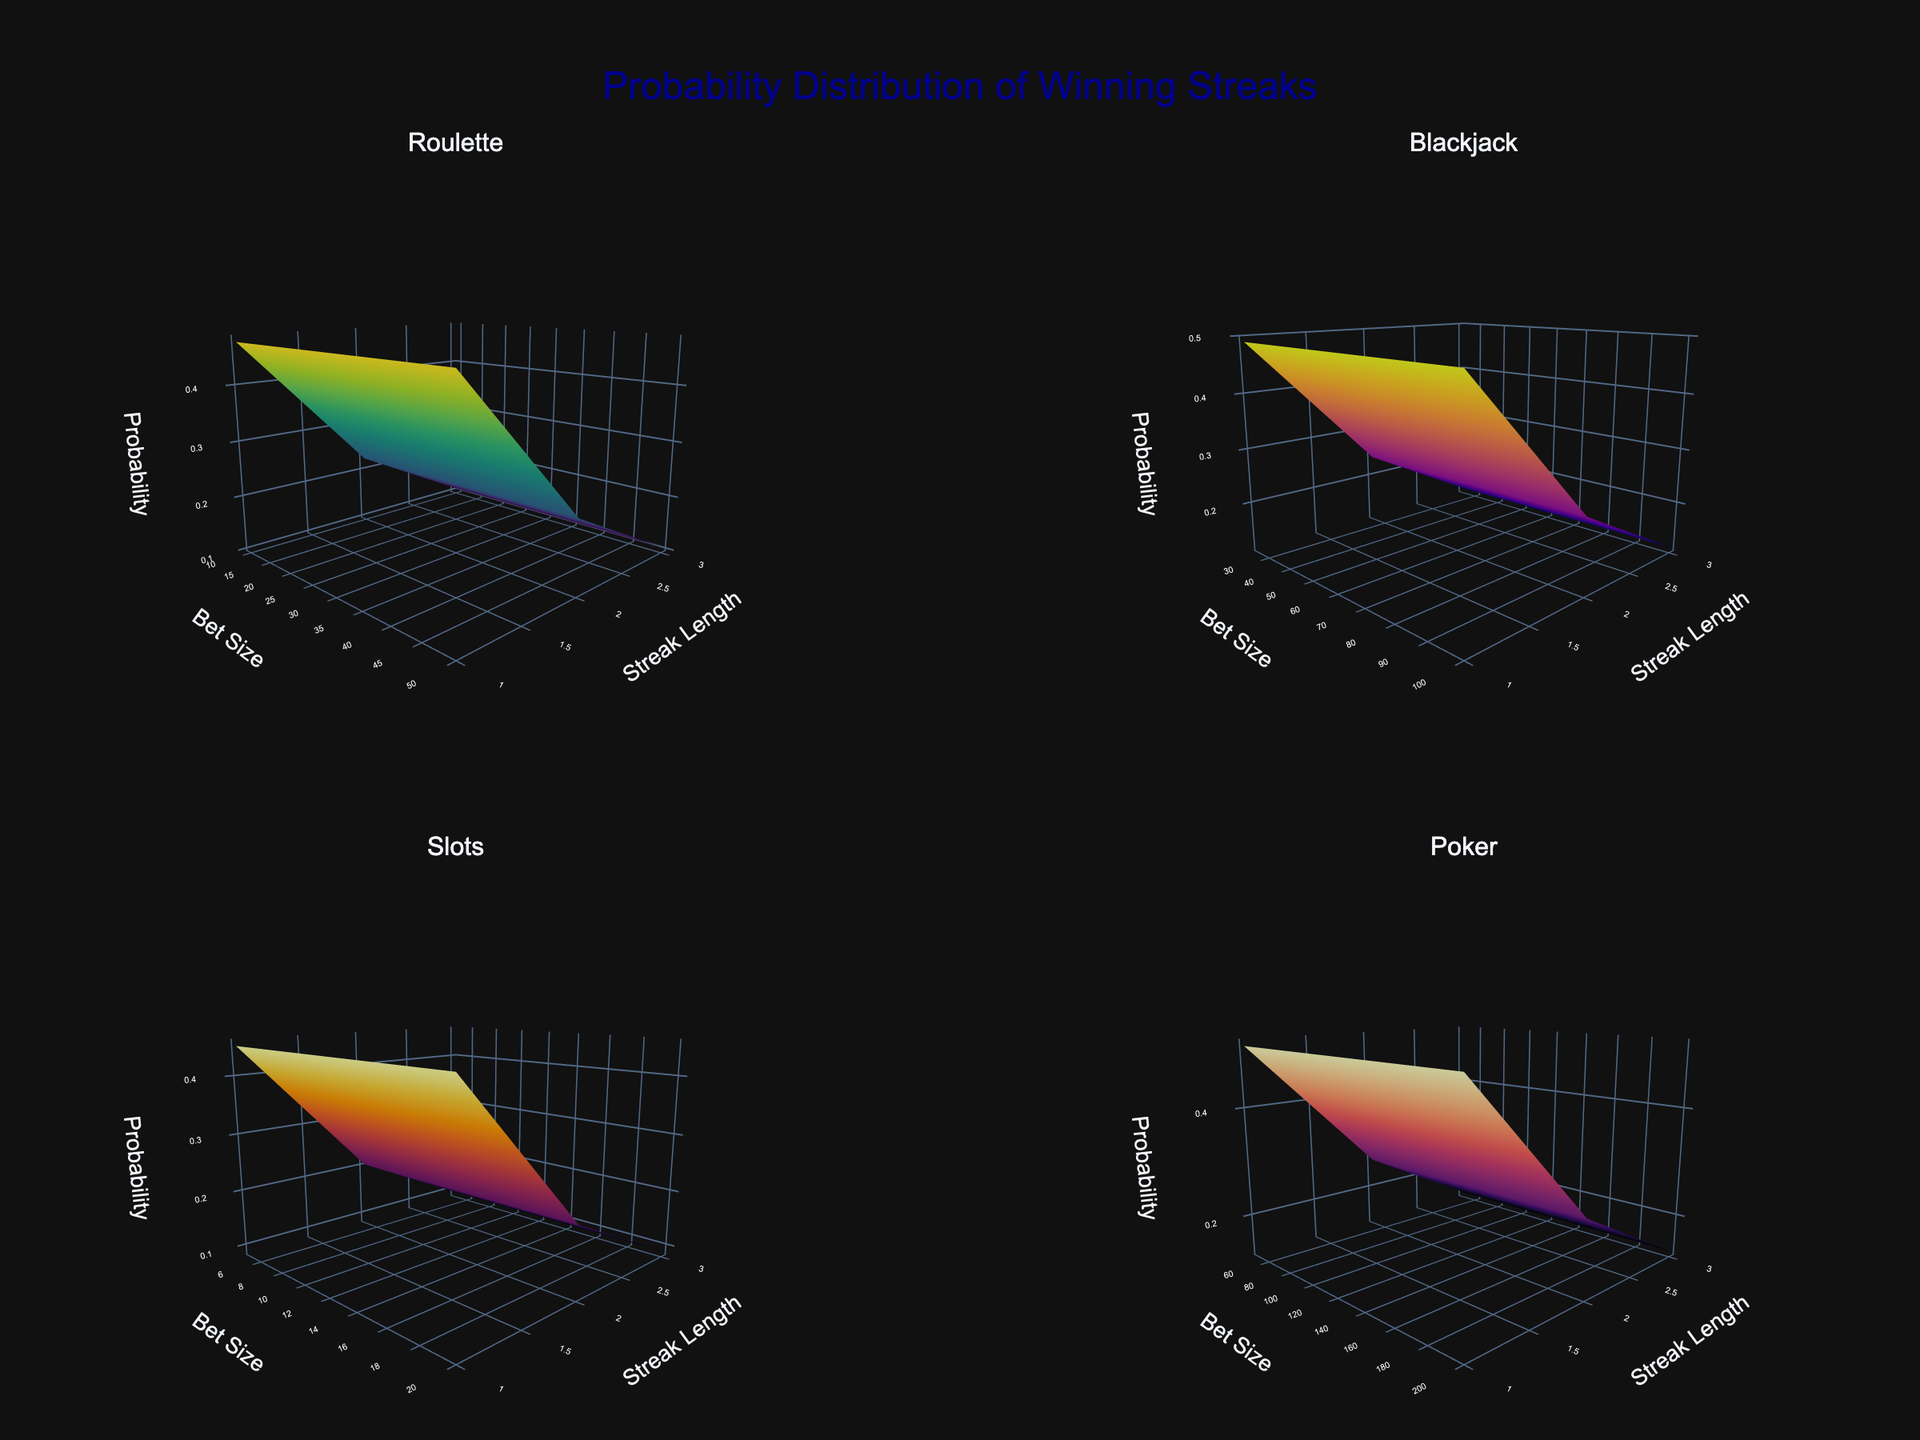What is the title of the figure? The title of the figure is displayed at the top and reads "Probability Distribution of Winning Streaks". This is indicated by the large, centered text at the top of the plot.
Answer: Probability Distribution of Winning Streaks Which game shows the highest probability for a streak length of 1 with the smallest bet size? By examining the first column of each subplot, we need to identify the highest point for a streak length of 1. For Roulette (Bet Size 10), Blackjack (Bet Size 25), Slots (Bet Size 5), and Poker (Bet Size 50), Poker shows the highest peak.
Answer: Poker What is the difference in probability for a streak length of 3 between Roulette and Blackjack with the largest bet size? Comparing the highest bet size for both games, Roulette (Bet Size 50, Prob 0.1064) and Blackjack (Bet Size 100, Prob 0.1176), the difference is 0.0112.
Answer: 0.0112 Which game has the least variation in probability across different bet sizes for a streak length of 2? Analyzing the probability distribution for a streak length of 2 across different bet sizes, Slots shows the most uniform values around 0.2025.
Answer: Slots For which game does the probability decrease most steeply from a streak length of 1 to a streak length of 3 for the smallest bet size? By comparing the slopes for each game, we observe that Slots (Bet Size 5) decreases from 0.4500 (streak length 1) to 0.0911 (streak length 3), which is the steepest drop.
Answer: Slots Which game subplot uses the 'Inferno' color scale? The third subplot (bottom left) represents the Slots game, which uses the 'Inferno' color scale, indicated by the specific visualization colors.
Answer: Slots What is the maximum probability for a streak length of 3 across all games and bet sizes? Reviewing all subplots for the highest peak at streak length 3, Poker with the smallest bet size (50) at probability 0.1326 is the maximum.
Answer: 0.1326 How does the camera angle affect the visualization in the subplots? The camera eye is set at {'x': 1.5, 'y': -1.5, 'z': 0.5}, providing a perspective that highlights the height difference across probabilities without obstructing visibility of any axis.
Answer: It provides a clear view of the probability differences 